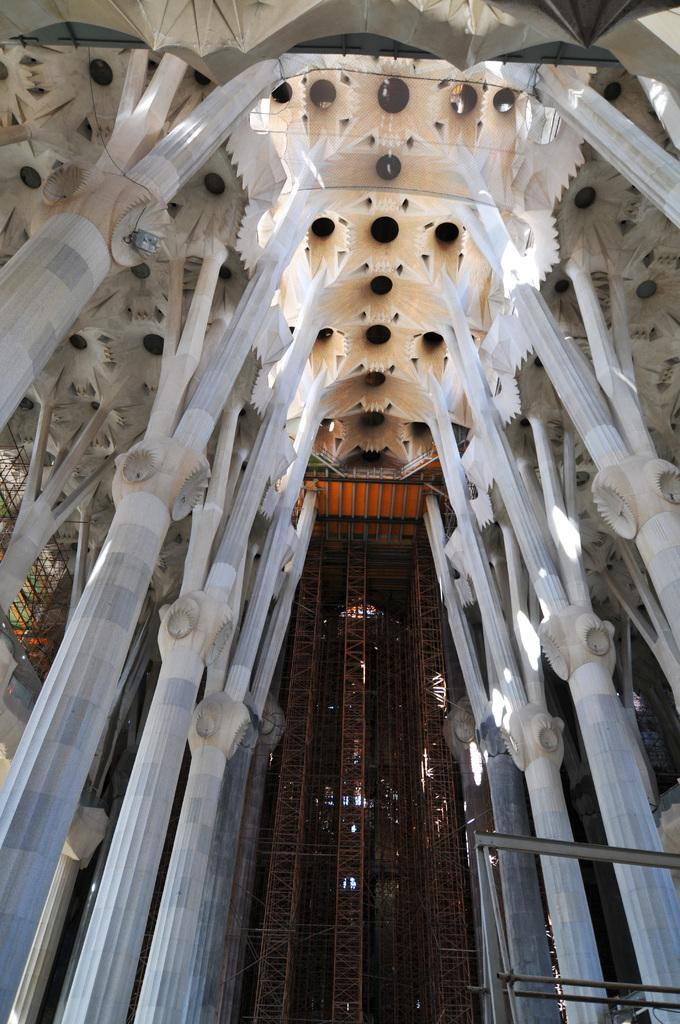What color are some of the objects in the image? Some of the objects in the image are white in color. What can be seen in the background of the image? There are rods in the background of the image. What type of bear can be seen making a discovery in the image? There is no bear or discovery present in the image. What kind of beetle is crawling on the rods in the background of the image? There are no beetles present in the image; only rods can be seen in the background. 